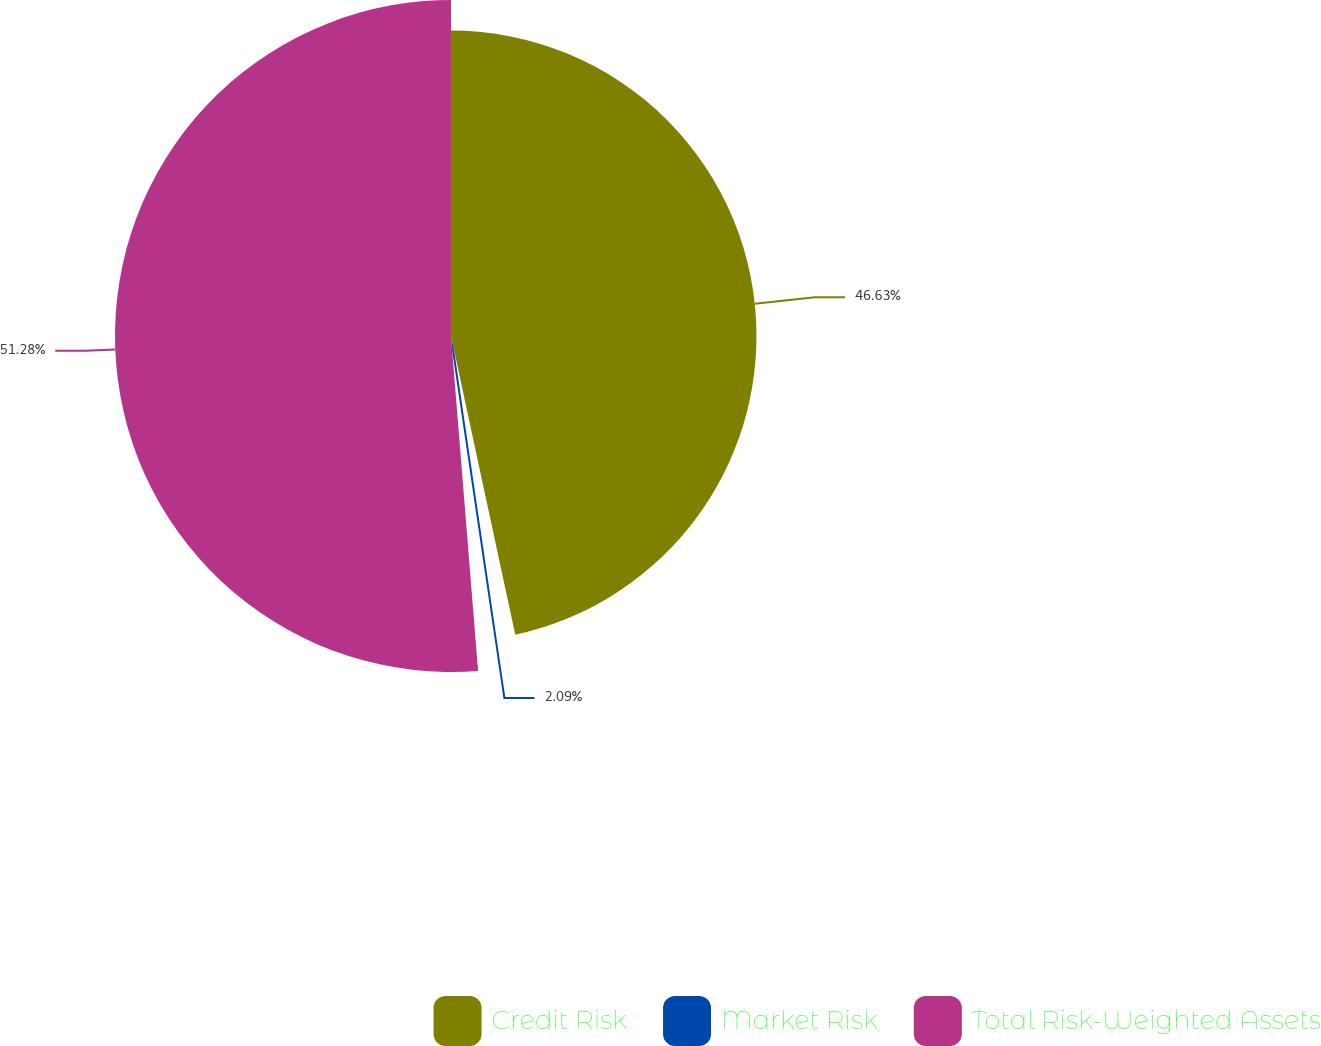<chart> <loc_0><loc_0><loc_500><loc_500><pie_chart><fcel>Credit Risk<fcel>Market Risk<fcel>Total Risk-Weighted Assets<nl><fcel>46.63%<fcel>2.09%<fcel>51.29%<nl></chart> 